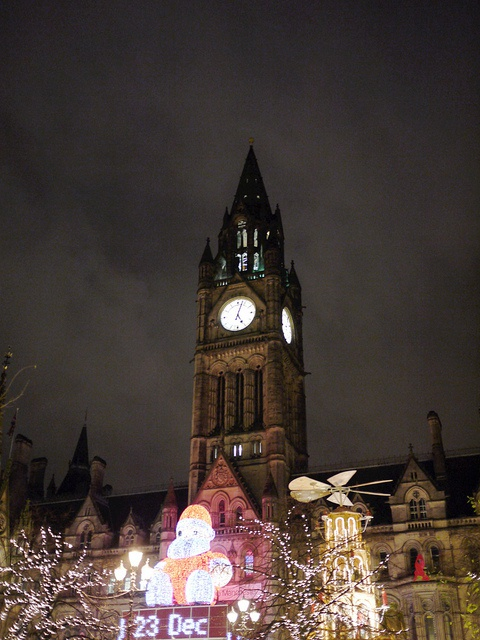Describe the objects in this image and their specific colors. I can see clock in black, whitesmoke, darkgray, and tan tones and clock in black, white, darkgray, tan, and navy tones in this image. 